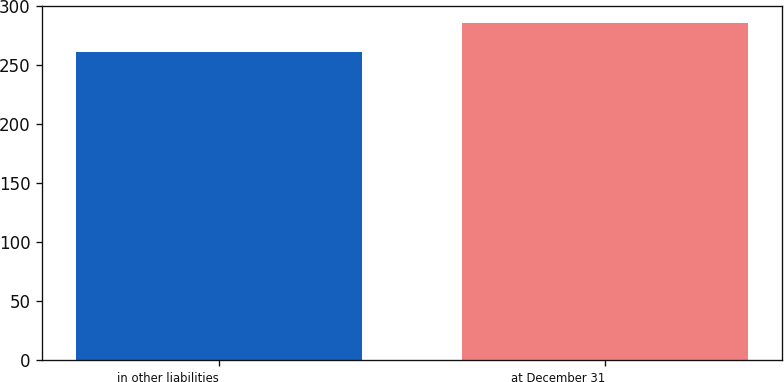<chart> <loc_0><loc_0><loc_500><loc_500><bar_chart><fcel>in other liabilities<fcel>at December 31<nl><fcel>261<fcel>286<nl></chart> 